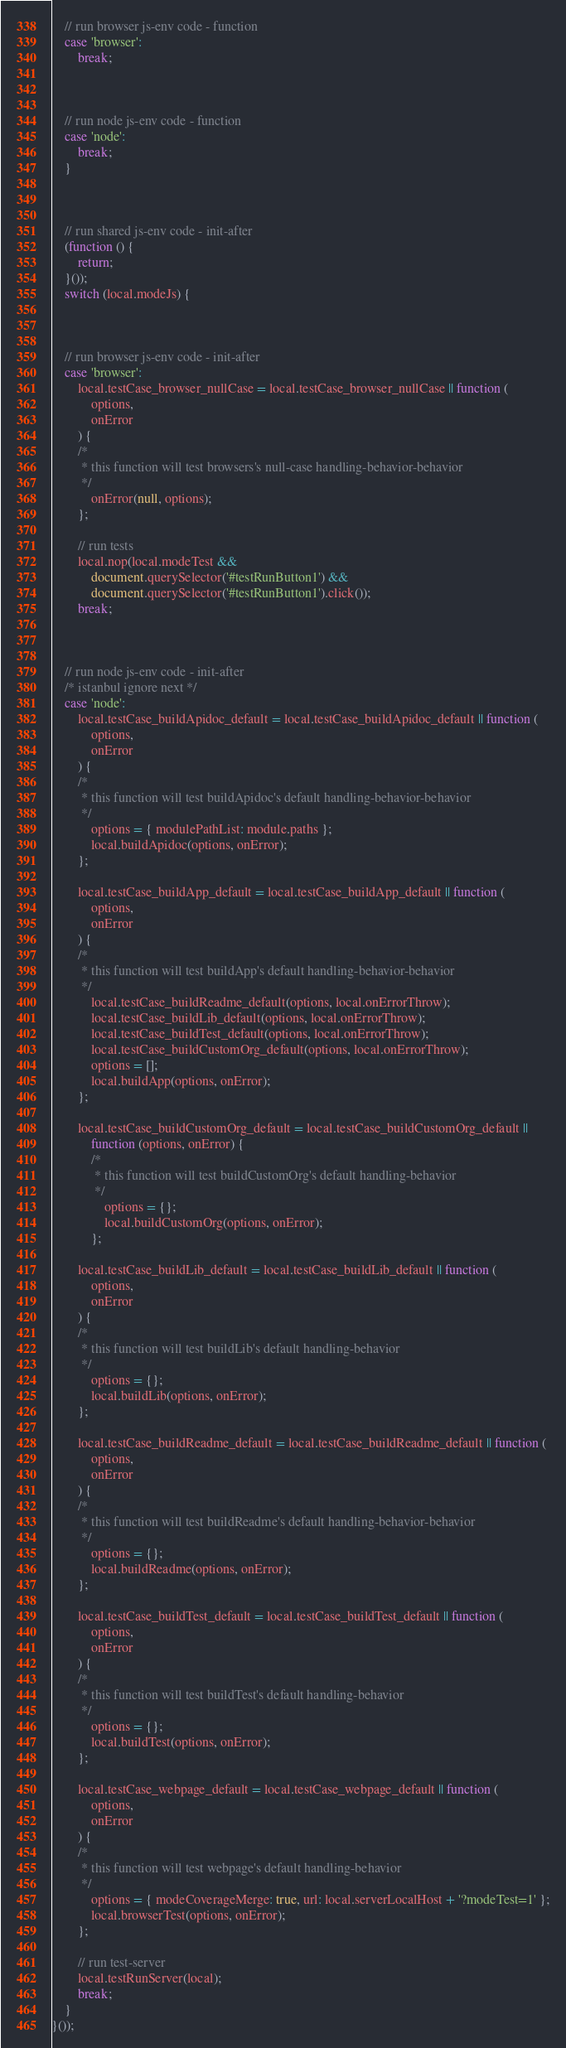<code> <loc_0><loc_0><loc_500><loc_500><_JavaScript_>


    // run browser js-env code - function
    case 'browser':
        break;



    // run node js-env code - function
    case 'node':
        break;
    }



    // run shared js-env code - init-after
    (function () {
        return;
    }());
    switch (local.modeJs) {



    // run browser js-env code - init-after
    case 'browser':
        local.testCase_browser_nullCase = local.testCase_browser_nullCase || function (
            options,
            onError
        ) {
        /*
         * this function will test browsers's null-case handling-behavior-behavior
         */
            onError(null, options);
        };

        // run tests
        local.nop(local.modeTest &&
            document.querySelector('#testRunButton1') &&
            document.querySelector('#testRunButton1').click());
        break;



    // run node js-env code - init-after
    /* istanbul ignore next */
    case 'node':
        local.testCase_buildApidoc_default = local.testCase_buildApidoc_default || function (
            options,
            onError
        ) {
        /*
         * this function will test buildApidoc's default handling-behavior-behavior
         */
            options = { modulePathList: module.paths };
            local.buildApidoc(options, onError);
        };

        local.testCase_buildApp_default = local.testCase_buildApp_default || function (
            options,
            onError
        ) {
        /*
         * this function will test buildApp's default handling-behavior-behavior
         */
            local.testCase_buildReadme_default(options, local.onErrorThrow);
            local.testCase_buildLib_default(options, local.onErrorThrow);
            local.testCase_buildTest_default(options, local.onErrorThrow);
            local.testCase_buildCustomOrg_default(options, local.onErrorThrow);
            options = [];
            local.buildApp(options, onError);
        };

        local.testCase_buildCustomOrg_default = local.testCase_buildCustomOrg_default ||
            function (options, onError) {
            /*
             * this function will test buildCustomOrg's default handling-behavior
             */
                options = {};
                local.buildCustomOrg(options, onError);
            };

        local.testCase_buildLib_default = local.testCase_buildLib_default || function (
            options,
            onError
        ) {
        /*
         * this function will test buildLib's default handling-behavior
         */
            options = {};
            local.buildLib(options, onError);
        };

        local.testCase_buildReadme_default = local.testCase_buildReadme_default || function (
            options,
            onError
        ) {
        /*
         * this function will test buildReadme's default handling-behavior-behavior
         */
            options = {};
            local.buildReadme(options, onError);
        };

        local.testCase_buildTest_default = local.testCase_buildTest_default || function (
            options,
            onError
        ) {
        /*
         * this function will test buildTest's default handling-behavior
         */
            options = {};
            local.buildTest(options, onError);
        };

        local.testCase_webpage_default = local.testCase_webpage_default || function (
            options,
            onError
        ) {
        /*
         * this function will test webpage's default handling-behavior
         */
            options = { modeCoverageMerge: true, url: local.serverLocalHost + '?modeTest=1' };
            local.browserTest(options, onError);
        };

        // run test-server
        local.testRunServer(local);
        break;
    }
}());
</code> 